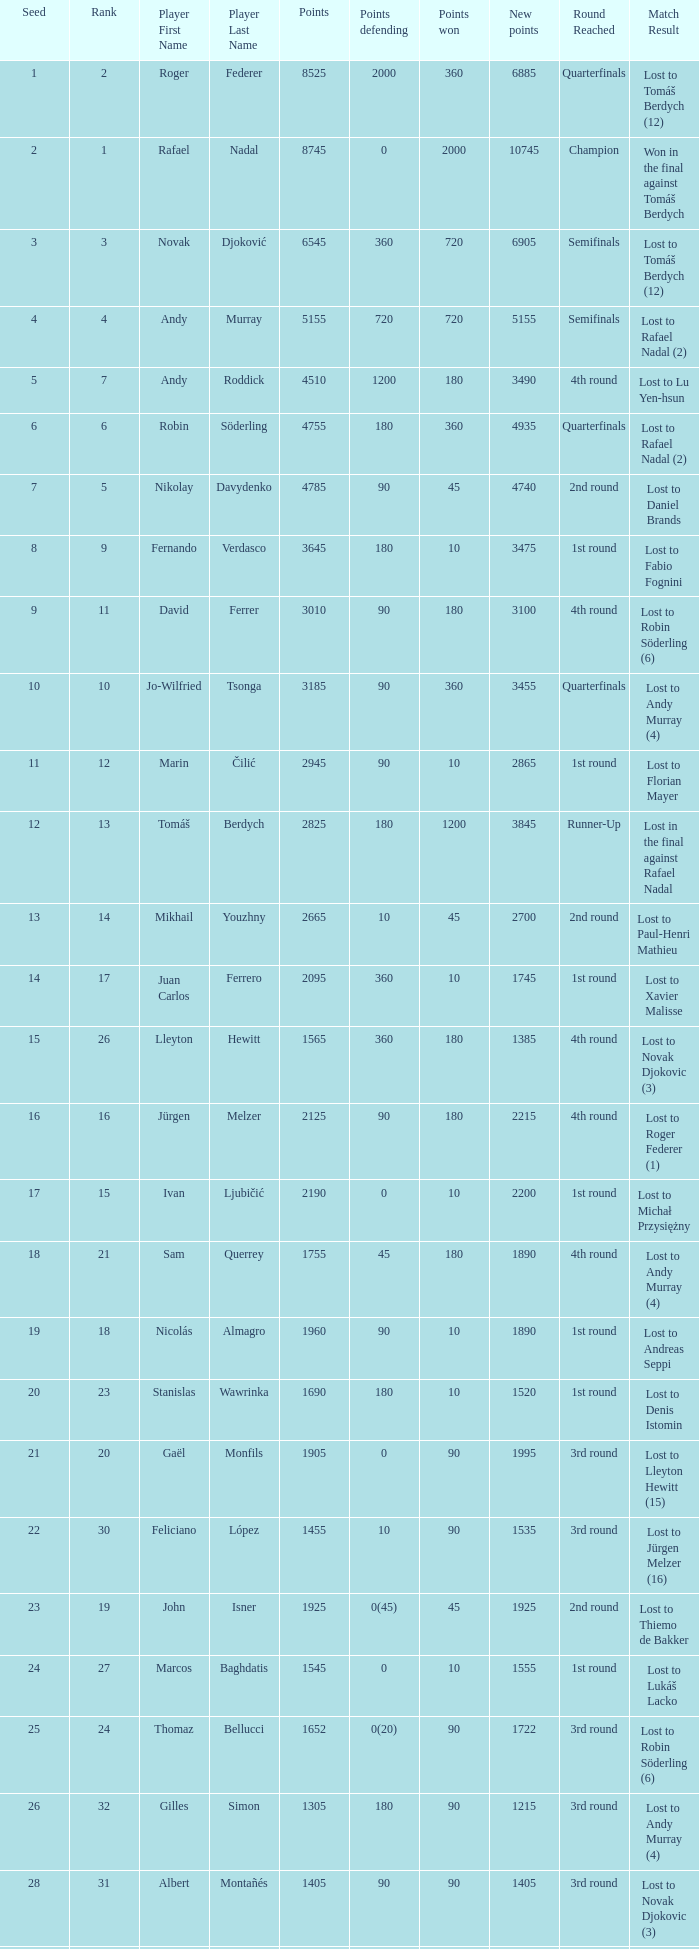Name the points won for 1230 90.0. 